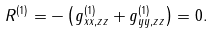Convert formula to latex. <formula><loc_0><loc_0><loc_500><loc_500>R ^ { ( 1 ) } = - \left ( g _ { x x , z z } ^ { ( 1 ) } + g _ { y y , z z } ^ { ( 1 ) } \right ) = 0 .</formula> 